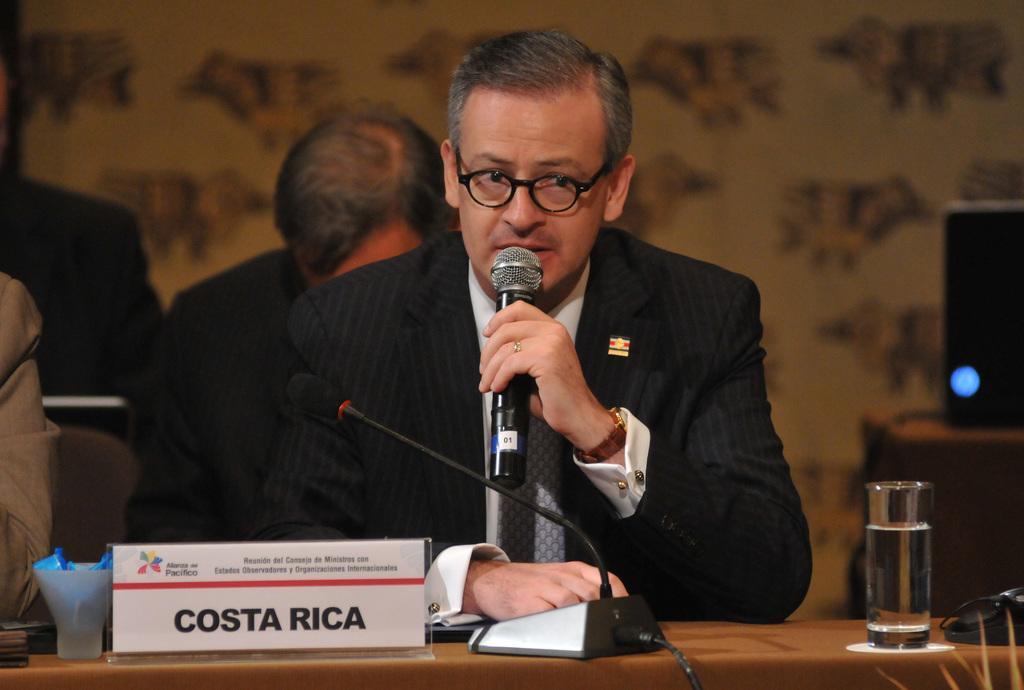How would you summarize this image in a sentence or two? In the middle of this image, there is a person in a suit, wearing a spectacle, holding a mic with a hand, speaking, sitting and placing a hand on a table, on which there is a mic attached to a stand, name board, glass and other objects. On the left side, there is another person. On the right side, there is a laptop placed on another table. In the background, there are two persons and a wall. 